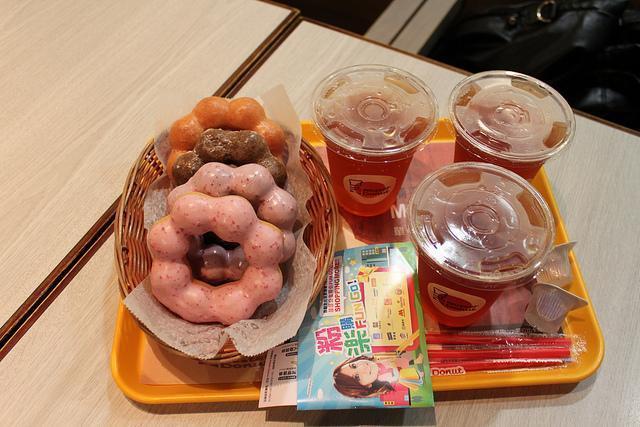How many cups are on the tray?
Give a very brief answer. 3. How many plates are here?
Give a very brief answer. 1. How many donuts can be seen?
Give a very brief answer. 4. How many cups are in the picture?
Give a very brief answer. 3. How many dining tables are visible?
Give a very brief answer. 2. How many people are there?
Give a very brief answer. 0. 